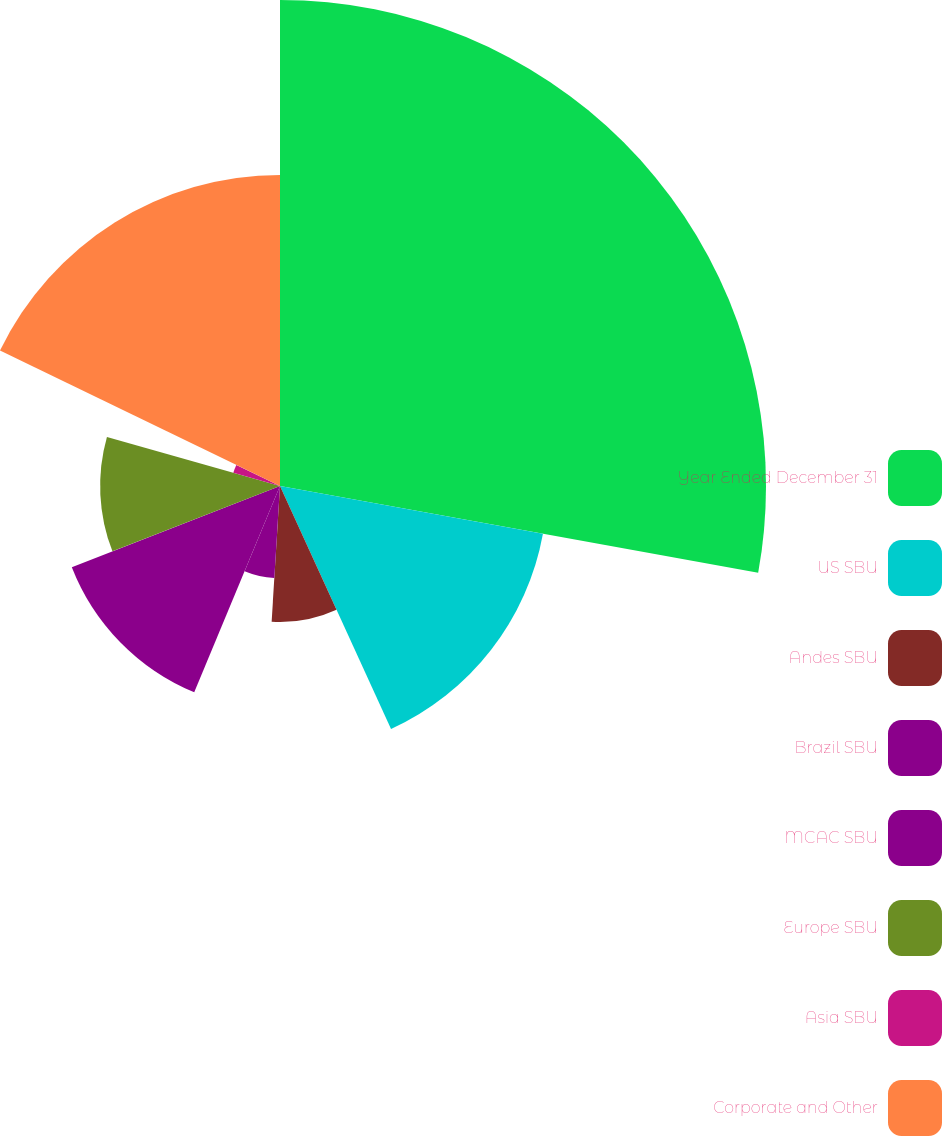Convert chart. <chart><loc_0><loc_0><loc_500><loc_500><pie_chart><fcel>Year Ended December 31<fcel>US SBU<fcel>Andes SBU<fcel>Brazil SBU<fcel>MCAC SBU<fcel>Europe SBU<fcel>Asia SBU<fcel>Corporate and Other<nl><fcel>27.86%<fcel>15.32%<fcel>7.8%<fcel>5.29%<fcel>12.81%<fcel>10.31%<fcel>2.78%<fcel>17.83%<nl></chart> 